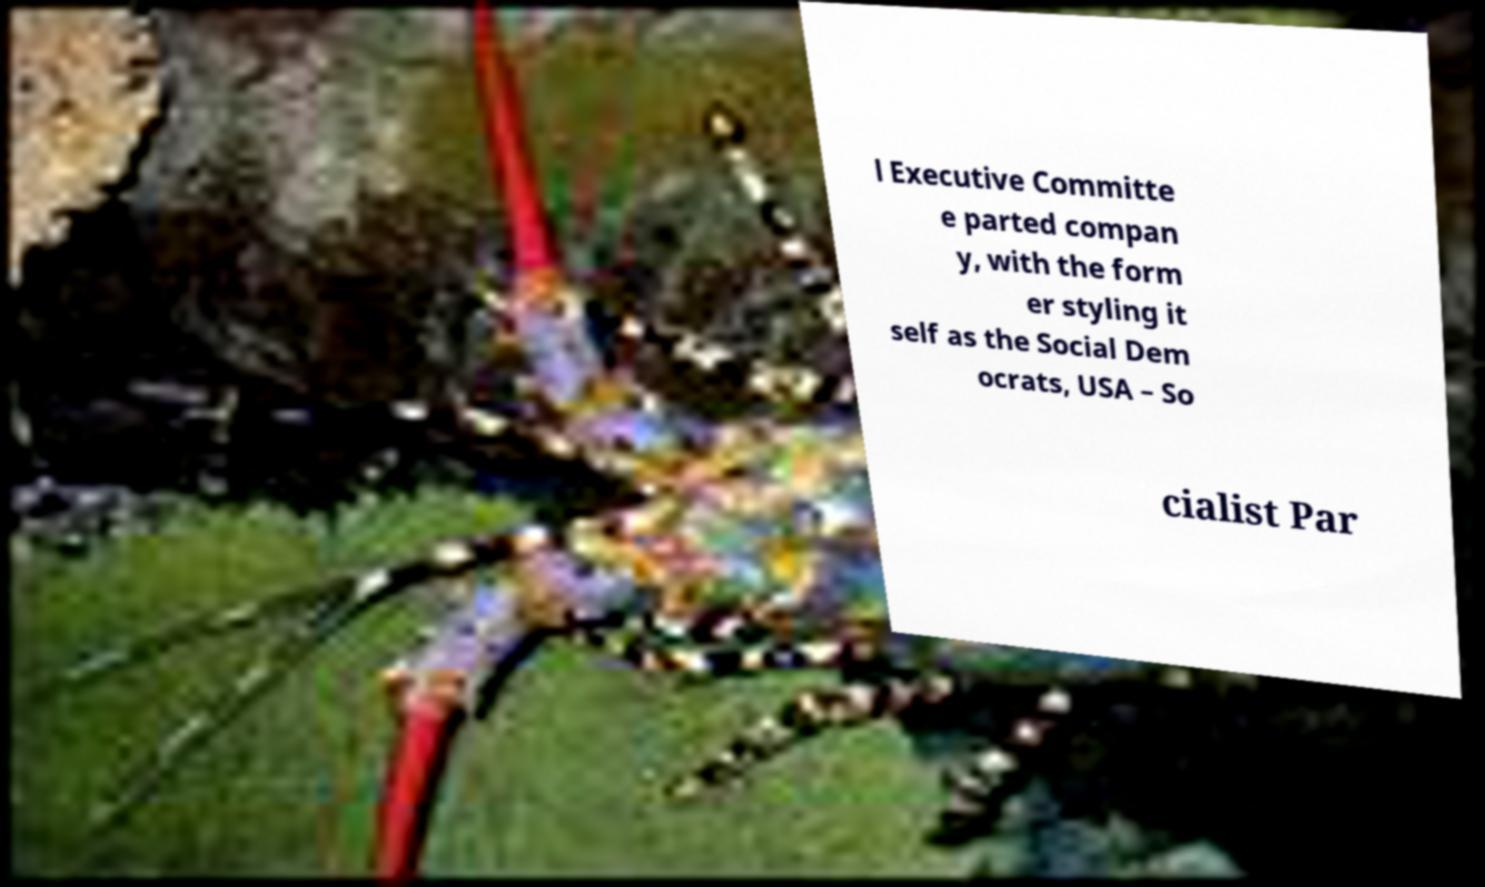I need the written content from this picture converted into text. Can you do that? l Executive Committe e parted compan y, with the form er styling it self as the Social Dem ocrats, USA – So cialist Par 